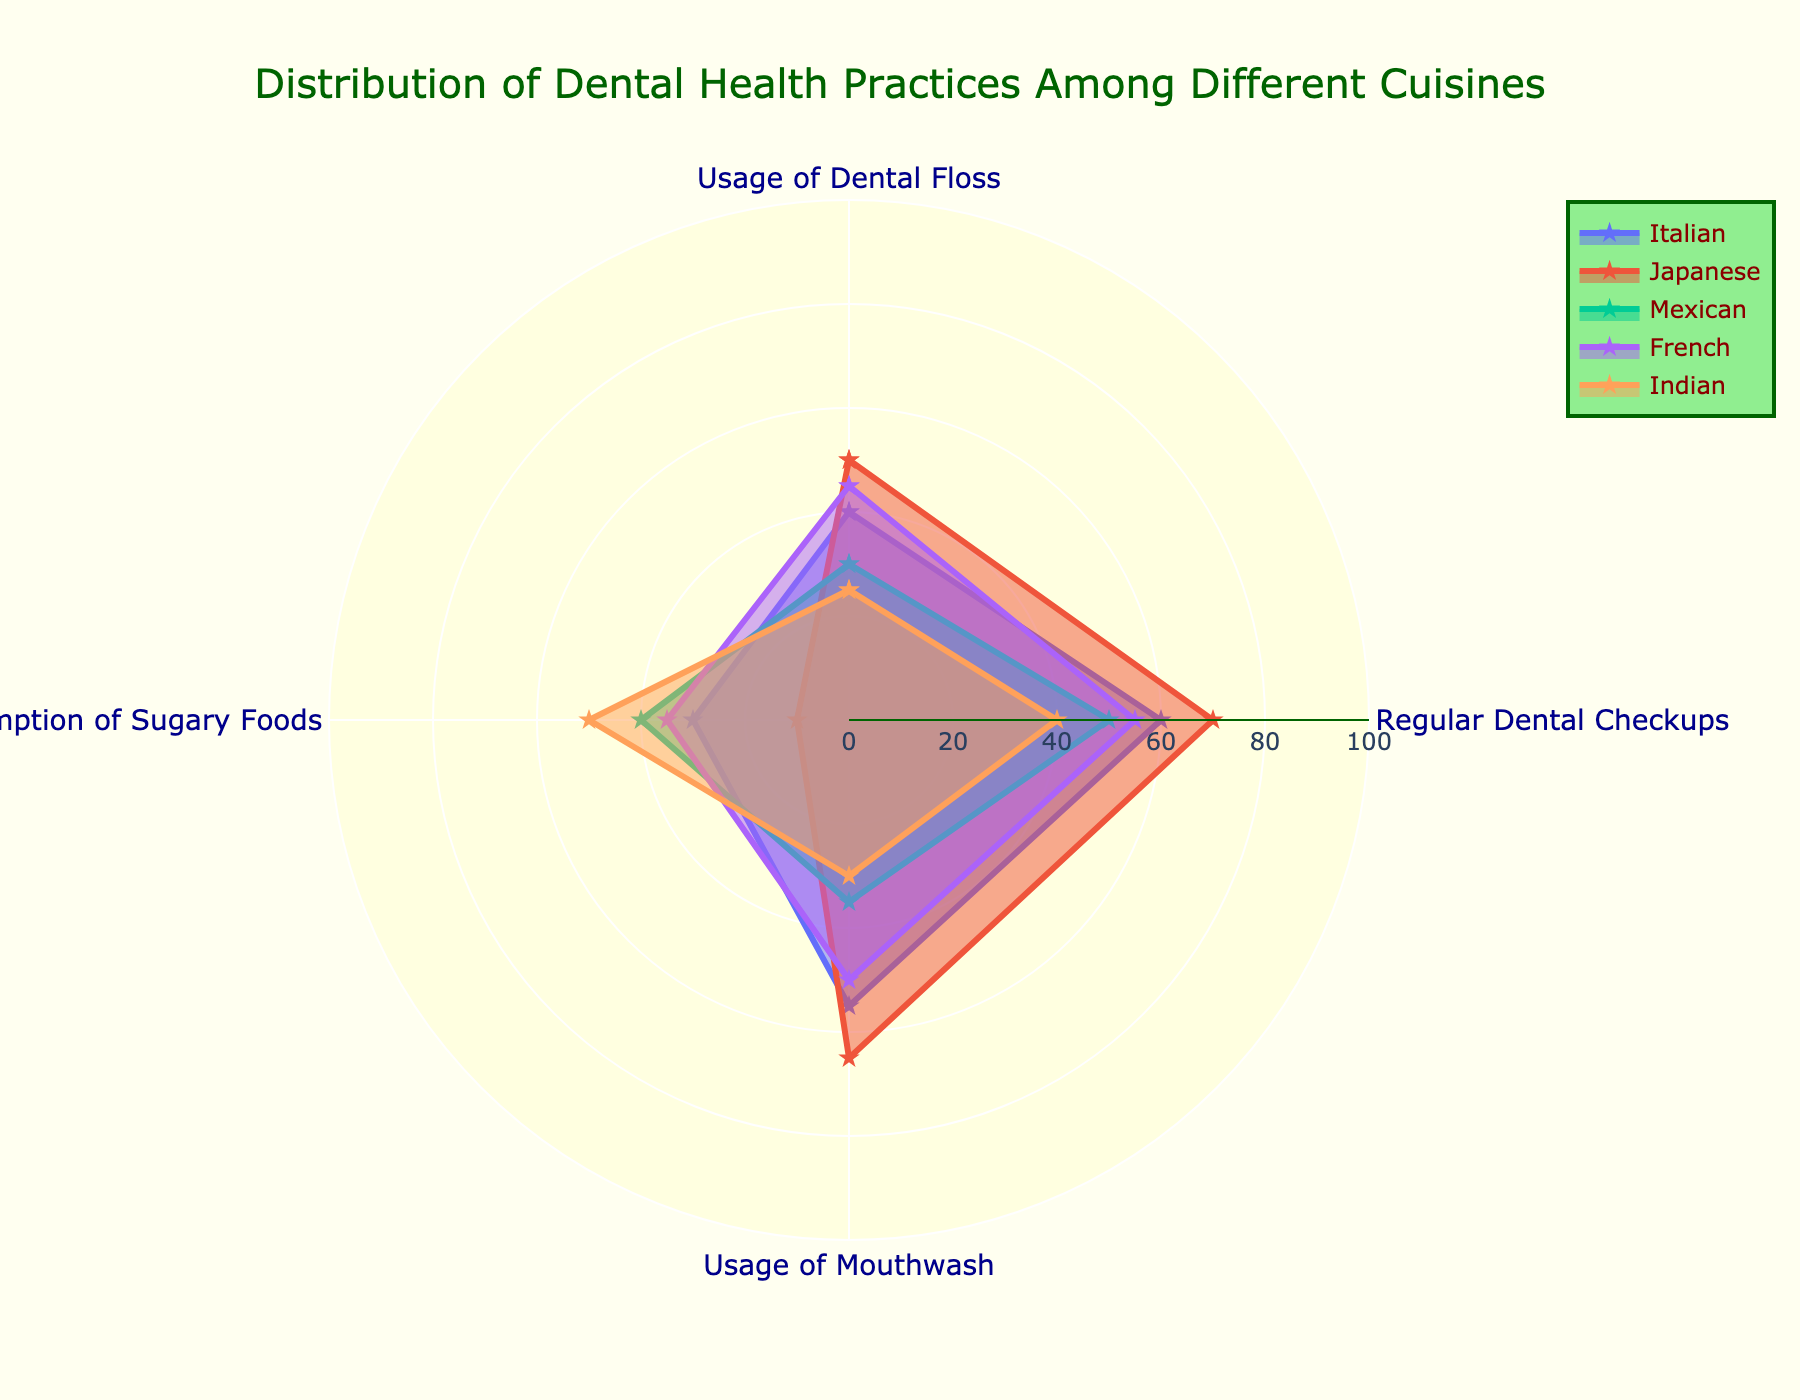What is the title of the figure? The title is generally found at the top of a plot and indicates what the figure is about. In this case, it's describing the distribution of dental health practices among different cuisines.
Answer: Distribution of Dental Health Practices Among Different Cuisines Which cuisine has the highest percentage for regular dental checkups? Look at the value on the 'Regular Dental Checkups' axis for each cuisine and identify which one is the highest. The highest value here is 70% for Japanese cuisine.
Answer: Japanese Which cuisine shows the highest consumption of sugary foods? Identify the values on the 'Consumption of Sugary Foods' axis for each cuisine and find the highest value. The highest value here is 50% for Indian cuisine.
Answer: Indian Compare the usage of mouthwash between Italian and French cuisines. Which one is greater? Look at the values on the 'Usage of Mouthwash' axis for Italian and French cuisines and compare them. The values are 55% for Italian and 50% for French, so Italian is greater.
Answer: Italian What's the average percentage of dental floss usage across all cuisines? Find the values for 'Usage of Dental Floss' for all cuisines, sum them up and divide by the number of cuisines: (40 + 50 + 30 + 45 + 25) / 5 = 38%.
Answer: 38% Which cuisine has the lowest percentage for usage of dental floss? Identify the values on the 'Usage of Dental Floss' axis for each cuisine and find the lowest value, which is 25% for Indian cuisine.
Answer: Indian What is the range of percentages represented in the radial axis of the figure? The radial axis represents the range of percentages from 0 to 100. The range is given in the axis specifications.
Answer: 0 to 100 Compare the regular dental checkups between Japanese and Mexican cuisines, which one is higher, and by how much? Look at the values for 'Regular Dental Checkups' for both Japanese and Mexican cuisines, then subtract the lower value from the higher one: 70% (Japanese) - 50% (Mexican) = 20%.
Answer: Japanese by 20% Which cuisine has the most balanced distribution of practices, and why? A balanced distribution would have relatively equal values across all practices. Italian cuisine has values of 40%, 60%, 55%, and 30%, which are more balanced compared to the other cuisines with larger disparities.
Answer: Italian How does the percentage of regular dental checkups for French cuisine compare to the usage of mouthwash for Japanese cuisine? Compare the values directly: Regular Dental Checkups for French is 55% and Mouthwash for Japanese is 65%. Therefore, 65% (Japanese Usage of Mouthwash) > 55% (French Regular Dental Checkups).
Answer: Japanese Mouthwash is higher 